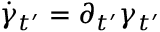<formula> <loc_0><loc_0><loc_500><loc_500>\dot { \gamma } _ { t ^ { \prime } } = \partial _ { t ^ { \prime } } \gamma _ { t ^ { \prime } }</formula> 